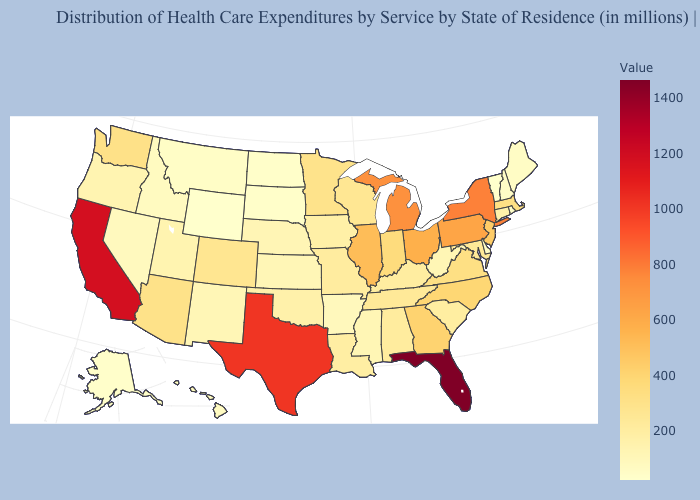Does Vermont have the lowest value in the USA?
Be succinct. Yes. Which states have the highest value in the USA?
Quick response, please. Florida. Which states hav the highest value in the West?
Short answer required. California. Is the legend a continuous bar?
Quick response, please. Yes. Among the states that border Iowa , which have the lowest value?
Concise answer only. South Dakota. Among the states that border New Hampshire , does Vermont have the lowest value?
Keep it brief. Yes. Is the legend a continuous bar?
Be succinct. Yes. 